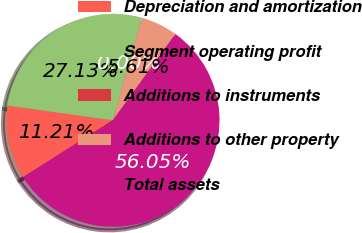<chart> <loc_0><loc_0><loc_500><loc_500><pie_chart><fcel>Depreciation and amortization<fcel>Segment operating profit<fcel>Additions to instruments<fcel>Additions to other property<fcel>Total assets<nl><fcel>11.21%<fcel>27.13%<fcel>0.0%<fcel>5.61%<fcel>56.04%<nl></chart> 